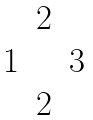<formula> <loc_0><loc_0><loc_500><loc_500>\begin{matrix} & 2 & \\ 1 & & 3 \\ & 2 \end{matrix}</formula> 